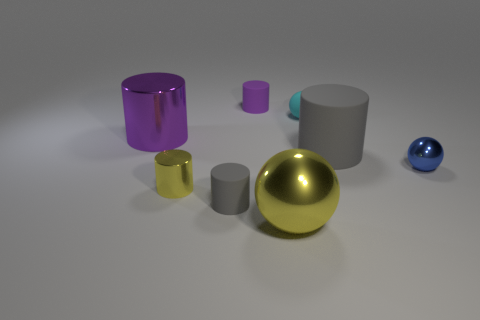Subtract all purple cylinders. Subtract all brown blocks. How many cylinders are left? 3 Add 1 large green cubes. How many objects exist? 9 Subtract all spheres. How many objects are left? 5 Subtract 2 purple cylinders. How many objects are left? 6 Subtract all small cyan metal blocks. Subtract all blue shiny balls. How many objects are left? 7 Add 8 big shiny objects. How many big shiny objects are left? 10 Add 8 purple cylinders. How many purple cylinders exist? 10 